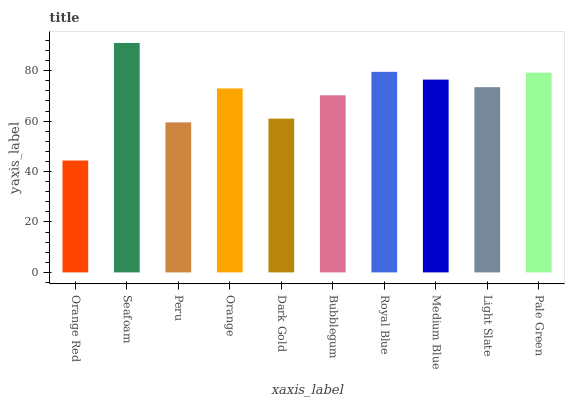Is Orange Red the minimum?
Answer yes or no. Yes. Is Seafoam the maximum?
Answer yes or no. Yes. Is Peru the minimum?
Answer yes or no. No. Is Peru the maximum?
Answer yes or no. No. Is Seafoam greater than Peru?
Answer yes or no. Yes. Is Peru less than Seafoam?
Answer yes or no. Yes. Is Peru greater than Seafoam?
Answer yes or no. No. Is Seafoam less than Peru?
Answer yes or no. No. Is Light Slate the high median?
Answer yes or no. Yes. Is Orange the low median?
Answer yes or no. Yes. Is Pale Green the high median?
Answer yes or no. No. Is Peru the low median?
Answer yes or no. No. 